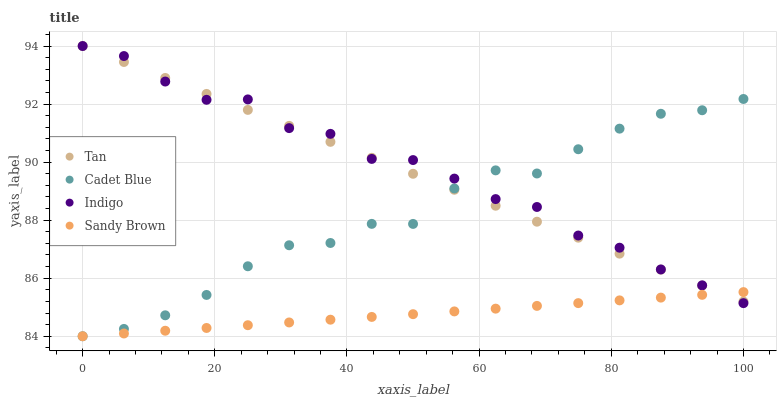Does Sandy Brown have the minimum area under the curve?
Answer yes or no. Yes. Does Indigo have the maximum area under the curve?
Answer yes or no. Yes. Does Tan have the minimum area under the curve?
Answer yes or no. No. Does Tan have the maximum area under the curve?
Answer yes or no. No. Is Tan the smoothest?
Answer yes or no. Yes. Is Indigo the roughest?
Answer yes or no. Yes. Is Cadet Blue the smoothest?
Answer yes or no. No. Is Cadet Blue the roughest?
Answer yes or no. No. Does Sandy Brown have the lowest value?
Answer yes or no. Yes. Does Tan have the lowest value?
Answer yes or no. No. Does Indigo have the highest value?
Answer yes or no. Yes. Does Cadet Blue have the highest value?
Answer yes or no. No. Does Sandy Brown intersect Indigo?
Answer yes or no. Yes. Is Sandy Brown less than Indigo?
Answer yes or no. No. Is Sandy Brown greater than Indigo?
Answer yes or no. No. 